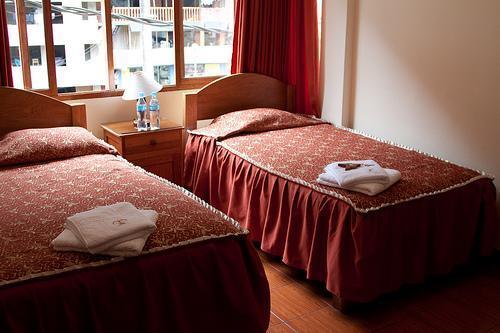How many towels are shown?
Give a very brief answer. 4. How many pillows are each bed?
Give a very brief answer. 1. How many bottles of water?
Give a very brief answer. 2. How many beds are shown?
Give a very brief answer. 2. How many beds are in the room?
Give a very brief answer. 2. 